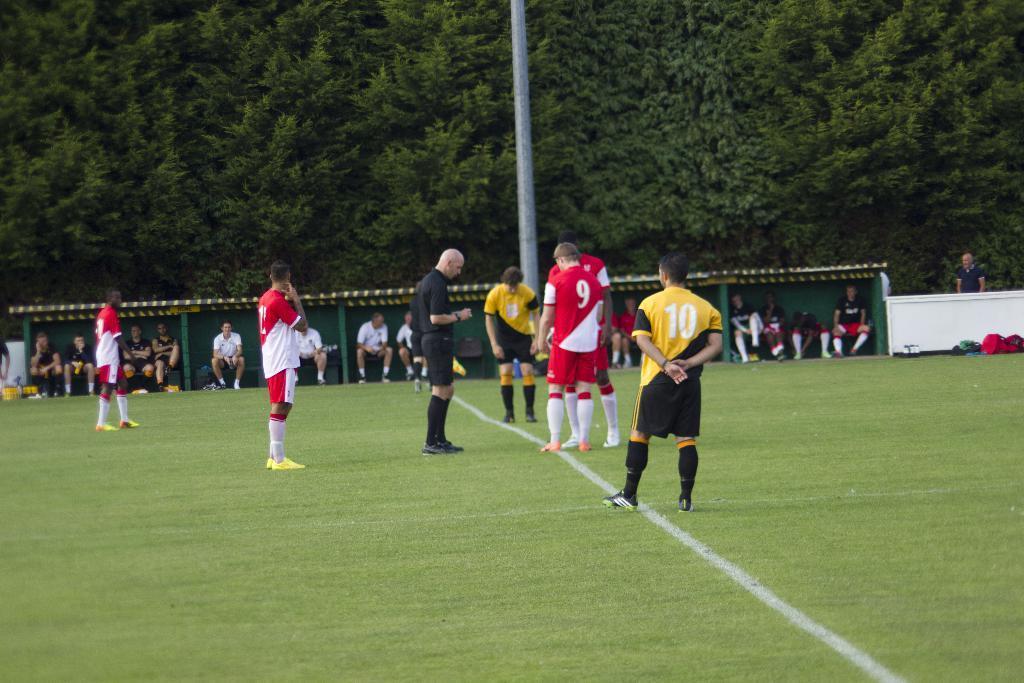In one or two sentences, can you explain what this image depicts? In this picture there are people in the center of the image, it seems to be a playground, there is shed in the center of the image and there is grass land at the bottom side of the image, there are trees at the top side of the image. 